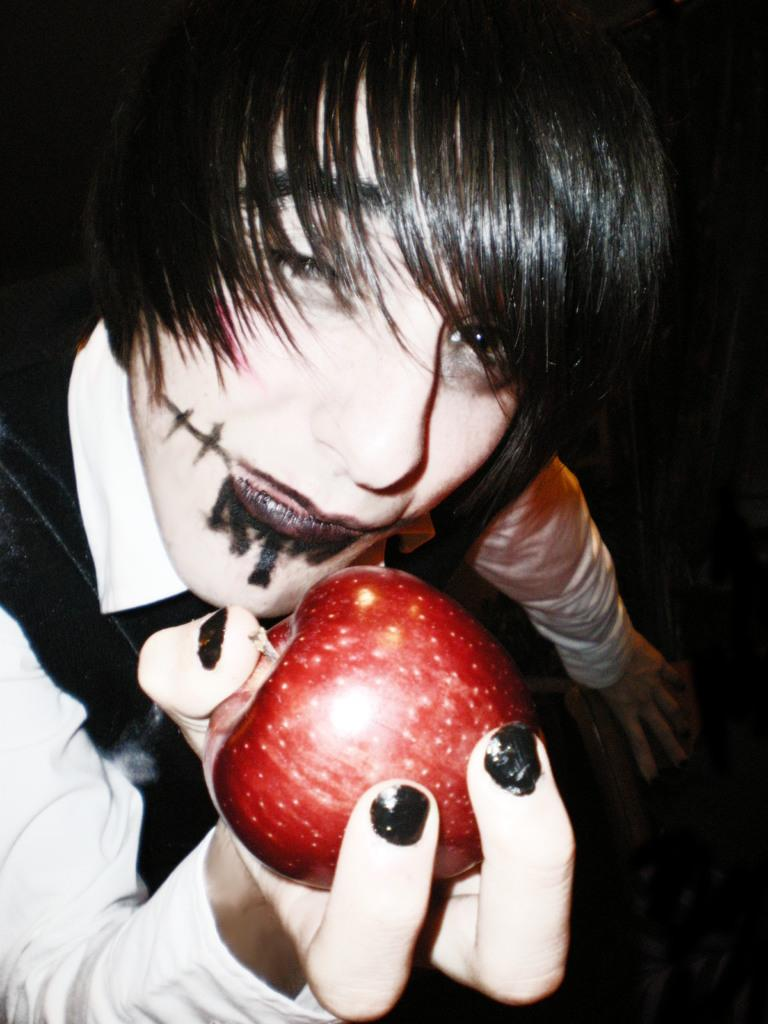Who or what is the main subject in the image? There is a person in the image. What is the person holding in the image? The person is holding an apple. What else is the person holding in the image? The person is holding an object. Can you describe the background of the image? The background of the image is dark. What type of oven can be seen in the image? There is no oven present in the image. 